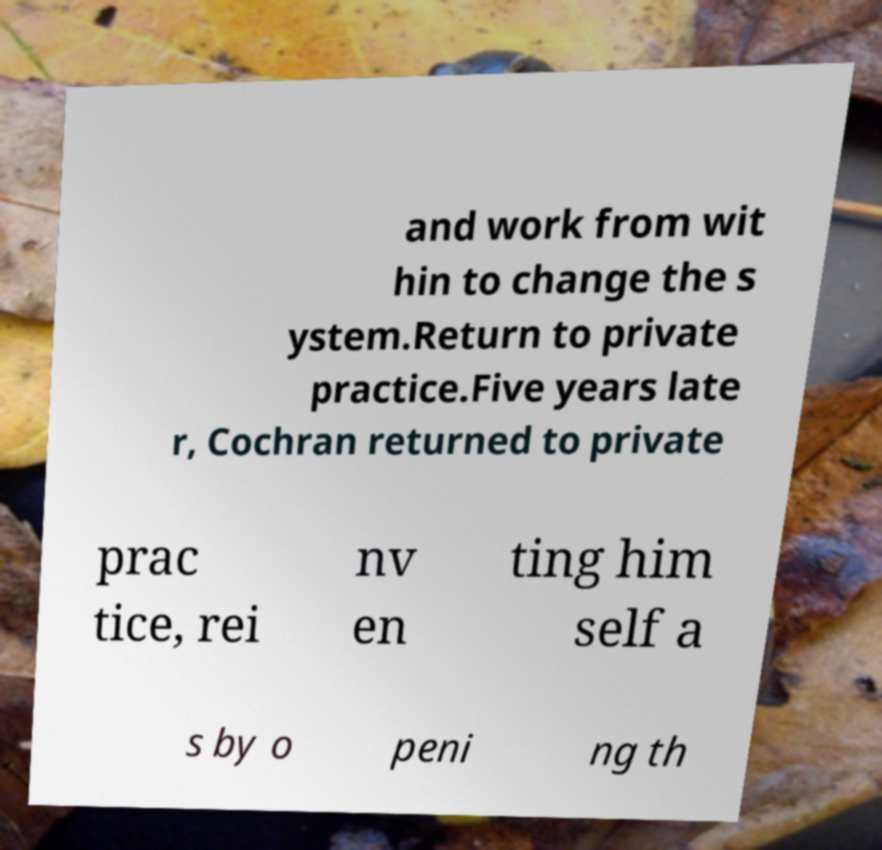Can you read and provide the text displayed in the image?This photo seems to have some interesting text. Can you extract and type it out for me? and work from wit hin to change the s ystem.Return to private practice.Five years late r, Cochran returned to private prac tice, rei nv en ting him self a s by o peni ng th 